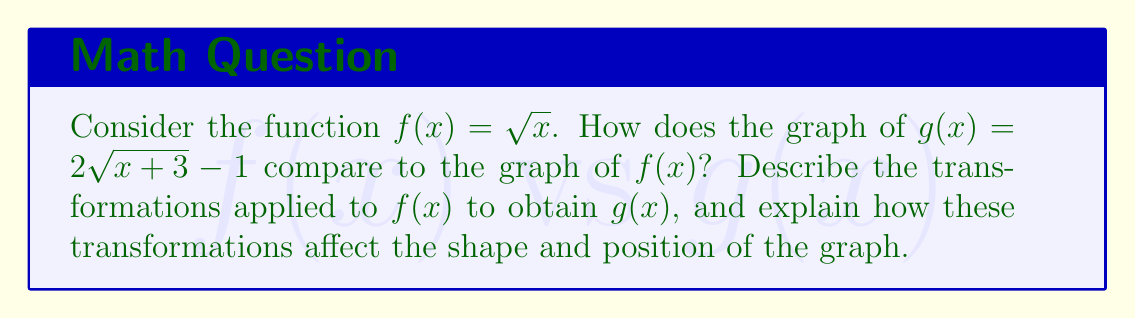Solve this math problem. Let's break down the transformations step-by-step:

1. Inside the square root: $x$ becomes $(x+3)$
   This is a horizontal shift 3 units to the left. We move the input left before applying the function.

2. Outside the square root: Multiply by 2
   This is a vertical stretch by a factor of 2. The graph will be twice as tall.

3. After all other operations: Subtract 1
   This is a vertical shift 1 unit down. We move the output down after applying the function.

To visualize these transformations:

1. Start with $f(x) = \sqrt{x}$
2. Shift left 3 units: $\sqrt{x+3}$
3. Stretch vertically by factor of 2: $2\sqrt{x+3}$
4. Shift down 1 unit: $2\sqrt{x+3} - 1$

The order of applying these transformations matters:
- Horizontal shifts and stretches are applied first (inside the function)
- Vertical stretches are applied next
- Vertical shifts are applied last

The final effect on the graph:
- The vertex of the parabola moves from (0,0) to (-3,-1)
- The parabola is twice as steep as the original
- All y-values are doubled and then decreased by 1

[asy]
import graph;
size(200);
real f(real x) {return sqrt(x);}
real g(real x) {return 2*sqrt(x+3) - 1;}
draw(graph(f,0,4), blue);
draw(graph(g,-3,1), red);
xaxis("x");
yaxis("y");
label("$f(x)=\sqrt{x}$", (3,1.5), blue);
label("$g(x)=2\sqrt{x+3}-1$", (-1,1), red);
[/asy]
Answer: The graph of $g(x) = 2\sqrt{x+3} - 1$ is obtained from $f(x) = \sqrt{x}$ by:
1. Shifting 3 units left
2. Stretching vertically by a factor of 2
3. Shifting 1 unit down
The resulting graph is steeper, with its vertex at (-3,-1) instead of (0,0). 